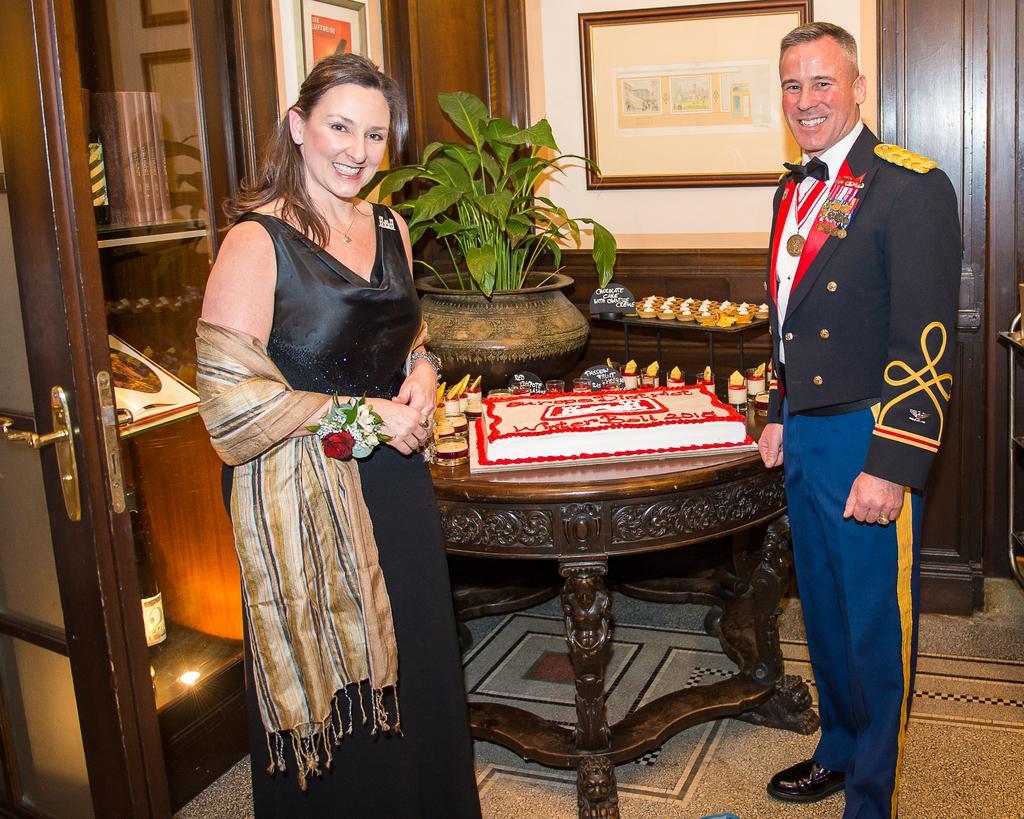Please provide a concise description of this image. In this there were two persons. A woman was standing towards the left and she is wearing a black frock and cream scarf, towards the right there is a man and he is wearing a black blazer, blue pants and black shoes. There is a table between them,. In the background there is a plant and a frame. In the left corner there is a desk, books and bottles are filled with it. There is a door in the right 